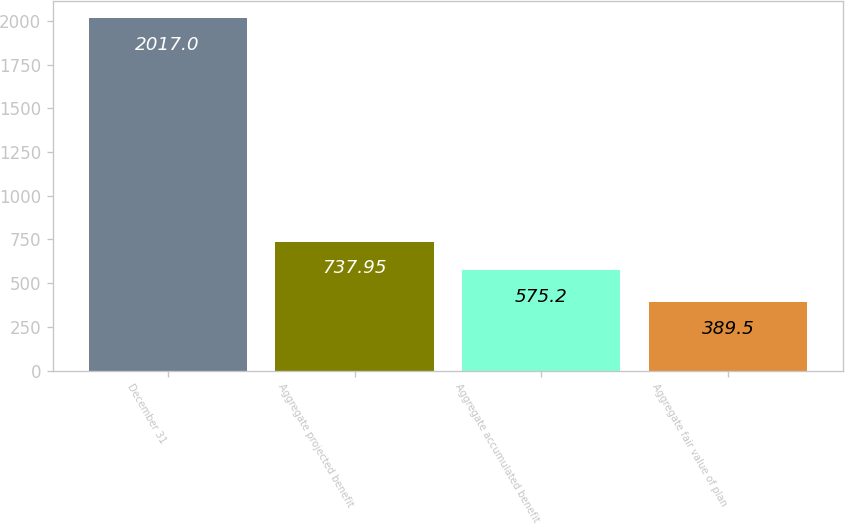Convert chart. <chart><loc_0><loc_0><loc_500><loc_500><bar_chart><fcel>December 31<fcel>Aggregate projected benefit<fcel>Aggregate accumulated benefit<fcel>Aggregate fair value of plan<nl><fcel>2017<fcel>737.95<fcel>575.2<fcel>389.5<nl></chart> 